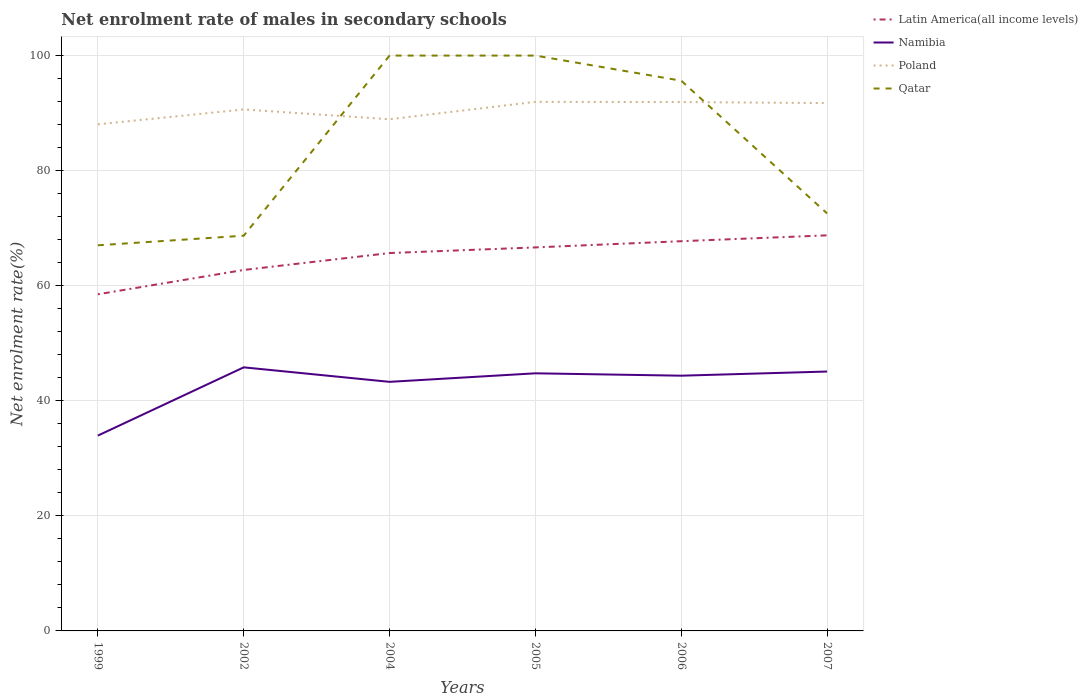Across all years, what is the maximum net enrolment rate of males in secondary schools in Namibia?
Offer a very short reply. 33.95. What is the total net enrolment rate of males in secondary schools in Poland in the graph?
Your response must be concise. -2.58. What is the difference between the highest and the second highest net enrolment rate of males in secondary schools in Poland?
Offer a terse response. 3.9. How many lines are there?
Your answer should be very brief. 4. How many years are there in the graph?
Provide a short and direct response. 6. Are the values on the major ticks of Y-axis written in scientific E-notation?
Ensure brevity in your answer.  No. How are the legend labels stacked?
Provide a succinct answer. Vertical. What is the title of the graph?
Make the answer very short. Net enrolment rate of males in secondary schools. Does "Ukraine" appear as one of the legend labels in the graph?
Provide a succinct answer. No. What is the label or title of the X-axis?
Provide a succinct answer. Years. What is the label or title of the Y-axis?
Provide a succinct answer. Net enrolment rate(%). What is the Net enrolment rate(%) of Latin America(all income levels) in 1999?
Offer a terse response. 58.51. What is the Net enrolment rate(%) in Namibia in 1999?
Your answer should be very brief. 33.95. What is the Net enrolment rate(%) of Poland in 1999?
Your response must be concise. 88.05. What is the Net enrolment rate(%) in Qatar in 1999?
Make the answer very short. 67.03. What is the Net enrolment rate(%) in Latin America(all income levels) in 2002?
Your answer should be compact. 62.74. What is the Net enrolment rate(%) in Namibia in 2002?
Give a very brief answer. 45.81. What is the Net enrolment rate(%) in Poland in 2002?
Keep it short and to the point. 90.64. What is the Net enrolment rate(%) of Qatar in 2002?
Offer a terse response. 68.69. What is the Net enrolment rate(%) of Latin America(all income levels) in 2004?
Give a very brief answer. 65.68. What is the Net enrolment rate(%) in Namibia in 2004?
Keep it short and to the point. 43.29. What is the Net enrolment rate(%) in Poland in 2004?
Offer a very short reply. 88.93. What is the Net enrolment rate(%) of Latin America(all income levels) in 2005?
Keep it short and to the point. 66.66. What is the Net enrolment rate(%) in Namibia in 2005?
Provide a short and direct response. 44.77. What is the Net enrolment rate(%) of Poland in 2005?
Your answer should be very brief. 91.96. What is the Net enrolment rate(%) in Latin America(all income levels) in 2006?
Your response must be concise. 67.74. What is the Net enrolment rate(%) in Namibia in 2006?
Your response must be concise. 44.36. What is the Net enrolment rate(%) in Poland in 2006?
Your response must be concise. 91.92. What is the Net enrolment rate(%) in Qatar in 2006?
Make the answer very short. 95.63. What is the Net enrolment rate(%) of Latin America(all income levels) in 2007?
Offer a terse response. 68.75. What is the Net enrolment rate(%) of Namibia in 2007?
Make the answer very short. 45.08. What is the Net enrolment rate(%) in Poland in 2007?
Offer a terse response. 91.74. What is the Net enrolment rate(%) in Qatar in 2007?
Give a very brief answer. 72.56. Across all years, what is the maximum Net enrolment rate(%) of Latin America(all income levels)?
Your answer should be very brief. 68.75. Across all years, what is the maximum Net enrolment rate(%) of Namibia?
Ensure brevity in your answer.  45.81. Across all years, what is the maximum Net enrolment rate(%) in Poland?
Offer a terse response. 91.96. Across all years, what is the minimum Net enrolment rate(%) in Latin America(all income levels)?
Keep it short and to the point. 58.51. Across all years, what is the minimum Net enrolment rate(%) in Namibia?
Your answer should be compact. 33.95. Across all years, what is the minimum Net enrolment rate(%) in Poland?
Provide a short and direct response. 88.05. Across all years, what is the minimum Net enrolment rate(%) in Qatar?
Ensure brevity in your answer.  67.03. What is the total Net enrolment rate(%) of Latin America(all income levels) in the graph?
Your answer should be compact. 390.08. What is the total Net enrolment rate(%) of Namibia in the graph?
Offer a very short reply. 257.27. What is the total Net enrolment rate(%) in Poland in the graph?
Give a very brief answer. 543.24. What is the total Net enrolment rate(%) in Qatar in the graph?
Offer a very short reply. 503.91. What is the difference between the Net enrolment rate(%) of Latin America(all income levels) in 1999 and that in 2002?
Give a very brief answer. -4.23. What is the difference between the Net enrolment rate(%) in Namibia in 1999 and that in 2002?
Offer a very short reply. -11.86. What is the difference between the Net enrolment rate(%) in Poland in 1999 and that in 2002?
Offer a very short reply. -2.58. What is the difference between the Net enrolment rate(%) of Qatar in 1999 and that in 2002?
Your answer should be compact. -1.67. What is the difference between the Net enrolment rate(%) of Latin America(all income levels) in 1999 and that in 2004?
Your answer should be very brief. -7.17. What is the difference between the Net enrolment rate(%) in Namibia in 1999 and that in 2004?
Offer a very short reply. -9.34. What is the difference between the Net enrolment rate(%) of Poland in 1999 and that in 2004?
Keep it short and to the point. -0.88. What is the difference between the Net enrolment rate(%) of Qatar in 1999 and that in 2004?
Your response must be concise. -32.97. What is the difference between the Net enrolment rate(%) in Latin America(all income levels) in 1999 and that in 2005?
Ensure brevity in your answer.  -8.15. What is the difference between the Net enrolment rate(%) in Namibia in 1999 and that in 2005?
Provide a succinct answer. -10.82. What is the difference between the Net enrolment rate(%) in Poland in 1999 and that in 2005?
Keep it short and to the point. -3.9. What is the difference between the Net enrolment rate(%) in Qatar in 1999 and that in 2005?
Keep it short and to the point. -32.97. What is the difference between the Net enrolment rate(%) of Latin America(all income levels) in 1999 and that in 2006?
Your answer should be compact. -9.23. What is the difference between the Net enrolment rate(%) of Namibia in 1999 and that in 2006?
Give a very brief answer. -10.41. What is the difference between the Net enrolment rate(%) of Poland in 1999 and that in 2006?
Make the answer very short. -3.87. What is the difference between the Net enrolment rate(%) in Qatar in 1999 and that in 2006?
Keep it short and to the point. -28.6. What is the difference between the Net enrolment rate(%) in Latin America(all income levels) in 1999 and that in 2007?
Your response must be concise. -10.24. What is the difference between the Net enrolment rate(%) in Namibia in 1999 and that in 2007?
Give a very brief answer. -11.13. What is the difference between the Net enrolment rate(%) of Poland in 1999 and that in 2007?
Give a very brief answer. -3.69. What is the difference between the Net enrolment rate(%) of Qatar in 1999 and that in 2007?
Your response must be concise. -5.53. What is the difference between the Net enrolment rate(%) of Latin America(all income levels) in 2002 and that in 2004?
Provide a short and direct response. -2.94. What is the difference between the Net enrolment rate(%) in Namibia in 2002 and that in 2004?
Ensure brevity in your answer.  2.52. What is the difference between the Net enrolment rate(%) of Poland in 2002 and that in 2004?
Your answer should be compact. 1.71. What is the difference between the Net enrolment rate(%) in Qatar in 2002 and that in 2004?
Ensure brevity in your answer.  -31.31. What is the difference between the Net enrolment rate(%) in Latin America(all income levels) in 2002 and that in 2005?
Give a very brief answer. -3.92. What is the difference between the Net enrolment rate(%) in Namibia in 2002 and that in 2005?
Make the answer very short. 1.04. What is the difference between the Net enrolment rate(%) in Poland in 2002 and that in 2005?
Make the answer very short. -1.32. What is the difference between the Net enrolment rate(%) of Qatar in 2002 and that in 2005?
Offer a very short reply. -31.31. What is the difference between the Net enrolment rate(%) of Latin America(all income levels) in 2002 and that in 2006?
Provide a short and direct response. -5. What is the difference between the Net enrolment rate(%) in Namibia in 2002 and that in 2006?
Ensure brevity in your answer.  1.45. What is the difference between the Net enrolment rate(%) of Poland in 2002 and that in 2006?
Offer a very short reply. -1.29. What is the difference between the Net enrolment rate(%) of Qatar in 2002 and that in 2006?
Offer a terse response. -26.94. What is the difference between the Net enrolment rate(%) of Latin America(all income levels) in 2002 and that in 2007?
Offer a terse response. -6.02. What is the difference between the Net enrolment rate(%) of Namibia in 2002 and that in 2007?
Keep it short and to the point. 0.73. What is the difference between the Net enrolment rate(%) of Poland in 2002 and that in 2007?
Your answer should be compact. -1.11. What is the difference between the Net enrolment rate(%) of Qatar in 2002 and that in 2007?
Your answer should be very brief. -3.87. What is the difference between the Net enrolment rate(%) in Latin America(all income levels) in 2004 and that in 2005?
Ensure brevity in your answer.  -0.98. What is the difference between the Net enrolment rate(%) in Namibia in 2004 and that in 2005?
Provide a short and direct response. -1.48. What is the difference between the Net enrolment rate(%) of Poland in 2004 and that in 2005?
Provide a succinct answer. -3.03. What is the difference between the Net enrolment rate(%) of Qatar in 2004 and that in 2005?
Provide a succinct answer. 0. What is the difference between the Net enrolment rate(%) of Latin America(all income levels) in 2004 and that in 2006?
Offer a very short reply. -2.06. What is the difference between the Net enrolment rate(%) of Namibia in 2004 and that in 2006?
Provide a short and direct response. -1.07. What is the difference between the Net enrolment rate(%) in Poland in 2004 and that in 2006?
Offer a very short reply. -2.99. What is the difference between the Net enrolment rate(%) in Qatar in 2004 and that in 2006?
Your answer should be compact. 4.37. What is the difference between the Net enrolment rate(%) in Latin America(all income levels) in 2004 and that in 2007?
Keep it short and to the point. -3.08. What is the difference between the Net enrolment rate(%) of Namibia in 2004 and that in 2007?
Your answer should be very brief. -1.79. What is the difference between the Net enrolment rate(%) in Poland in 2004 and that in 2007?
Keep it short and to the point. -2.81. What is the difference between the Net enrolment rate(%) of Qatar in 2004 and that in 2007?
Your answer should be compact. 27.44. What is the difference between the Net enrolment rate(%) of Latin America(all income levels) in 2005 and that in 2006?
Offer a terse response. -1.08. What is the difference between the Net enrolment rate(%) in Namibia in 2005 and that in 2006?
Your answer should be compact. 0.41. What is the difference between the Net enrolment rate(%) in Poland in 2005 and that in 2006?
Provide a succinct answer. 0.03. What is the difference between the Net enrolment rate(%) of Qatar in 2005 and that in 2006?
Offer a very short reply. 4.37. What is the difference between the Net enrolment rate(%) of Latin America(all income levels) in 2005 and that in 2007?
Make the answer very short. -2.1. What is the difference between the Net enrolment rate(%) of Namibia in 2005 and that in 2007?
Your answer should be very brief. -0.31. What is the difference between the Net enrolment rate(%) in Poland in 2005 and that in 2007?
Ensure brevity in your answer.  0.21. What is the difference between the Net enrolment rate(%) in Qatar in 2005 and that in 2007?
Offer a terse response. 27.44. What is the difference between the Net enrolment rate(%) of Latin America(all income levels) in 2006 and that in 2007?
Ensure brevity in your answer.  -1.02. What is the difference between the Net enrolment rate(%) of Namibia in 2006 and that in 2007?
Your answer should be compact. -0.72. What is the difference between the Net enrolment rate(%) of Poland in 2006 and that in 2007?
Give a very brief answer. 0.18. What is the difference between the Net enrolment rate(%) in Qatar in 2006 and that in 2007?
Provide a short and direct response. 23.07. What is the difference between the Net enrolment rate(%) of Latin America(all income levels) in 1999 and the Net enrolment rate(%) of Namibia in 2002?
Offer a very short reply. 12.7. What is the difference between the Net enrolment rate(%) in Latin America(all income levels) in 1999 and the Net enrolment rate(%) in Poland in 2002?
Your answer should be very brief. -32.12. What is the difference between the Net enrolment rate(%) in Latin America(all income levels) in 1999 and the Net enrolment rate(%) in Qatar in 2002?
Ensure brevity in your answer.  -10.18. What is the difference between the Net enrolment rate(%) of Namibia in 1999 and the Net enrolment rate(%) of Poland in 2002?
Provide a short and direct response. -56.69. What is the difference between the Net enrolment rate(%) in Namibia in 1999 and the Net enrolment rate(%) in Qatar in 2002?
Provide a succinct answer. -34.74. What is the difference between the Net enrolment rate(%) of Poland in 1999 and the Net enrolment rate(%) of Qatar in 2002?
Provide a short and direct response. 19.36. What is the difference between the Net enrolment rate(%) of Latin America(all income levels) in 1999 and the Net enrolment rate(%) of Namibia in 2004?
Give a very brief answer. 15.22. What is the difference between the Net enrolment rate(%) of Latin America(all income levels) in 1999 and the Net enrolment rate(%) of Poland in 2004?
Your response must be concise. -30.42. What is the difference between the Net enrolment rate(%) of Latin America(all income levels) in 1999 and the Net enrolment rate(%) of Qatar in 2004?
Ensure brevity in your answer.  -41.49. What is the difference between the Net enrolment rate(%) of Namibia in 1999 and the Net enrolment rate(%) of Poland in 2004?
Offer a terse response. -54.98. What is the difference between the Net enrolment rate(%) of Namibia in 1999 and the Net enrolment rate(%) of Qatar in 2004?
Provide a short and direct response. -66.05. What is the difference between the Net enrolment rate(%) of Poland in 1999 and the Net enrolment rate(%) of Qatar in 2004?
Offer a very short reply. -11.95. What is the difference between the Net enrolment rate(%) in Latin America(all income levels) in 1999 and the Net enrolment rate(%) in Namibia in 2005?
Offer a terse response. 13.74. What is the difference between the Net enrolment rate(%) of Latin America(all income levels) in 1999 and the Net enrolment rate(%) of Poland in 2005?
Keep it short and to the point. -33.45. What is the difference between the Net enrolment rate(%) in Latin America(all income levels) in 1999 and the Net enrolment rate(%) in Qatar in 2005?
Offer a terse response. -41.49. What is the difference between the Net enrolment rate(%) in Namibia in 1999 and the Net enrolment rate(%) in Poland in 2005?
Your response must be concise. -58.01. What is the difference between the Net enrolment rate(%) in Namibia in 1999 and the Net enrolment rate(%) in Qatar in 2005?
Your answer should be very brief. -66.05. What is the difference between the Net enrolment rate(%) in Poland in 1999 and the Net enrolment rate(%) in Qatar in 2005?
Keep it short and to the point. -11.95. What is the difference between the Net enrolment rate(%) in Latin America(all income levels) in 1999 and the Net enrolment rate(%) in Namibia in 2006?
Provide a succinct answer. 14.15. What is the difference between the Net enrolment rate(%) in Latin America(all income levels) in 1999 and the Net enrolment rate(%) in Poland in 2006?
Make the answer very short. -33.41. What is the difference between the Net enrolment rate(%) of Latin America(all income levels) in 1999 and the Net enrolment rate(%) of Qatar in 2006?
Give a very brief answer. -37.12. What is the difference between the Net enrolment rate(%) in Namibia in 1999 and the Net enrolment rate(%) in Poland in 2006?
Your response must be concise. -57.97. What is the difference between the Net enrolment rate(%) of Namibia in 1999 and the Net enrolment rate(%) of Qatar in 2006?
Ensure brevity in your answer.  -61.68. What is the difference between the Net enrolment rate(%) of Poland in 1999 and the Net enrolment rate(%) of Qatar in 2006?
Keep it short and to the point. -7.58. What is the difference between the Net enrolment rate(%) in Latin America(all income levels) in 1999 and the Net enrolment rate(%) in Namibia in 2007?
Make the answer very short. 13.43. What is the difference between the Net enrolment rate(%) of Latin America(all income levels) in 1999 and the Net enrolment rate(%) of Poland in 2007?
Provide a succinct answer. -33.23. What is the difference between the Net enrolment rate(%) in Latin America(all income levels) in 1999 and the Net enrolment rate(%) in Qatar in 2007?
Provide a succinct answer. -14.05. What is the difference between the Net enrolment rate(%) in Namibia in 1999 and the Net enrolment rate(%) in Poland in 2007?
Offer a terse response. -57.79. What is the difference between the Net enrolment rate(%) in Namibia in 1999 and the Net enrolment rate(%) in Qatar in 2007?
Your answer should be very brief. -38.61. What is the difference between the Net enrolment rate(%) in Poland in 1999 and the Net enrolment rate(%) in Qatar in 2007?
Provide a succinct answer. 15.49. What is the difference between the Net enrolment rate(%) in Latin America(all income levels) in 2002 and the Net enrolment rate(%) in Namibia in 2004?
Offer a terse response. 19.45. What is the difference between the Net enrolment rate(%) in Latin America(all income levels) in 2002 and the Net enrolment rate(%) in Poland in 2004?
Your answer should be very brief. -26.19. What is the difference between the Net enrolment rate(%) in Latin America(all income levels) in 2002 and the Net enrolment rate(%) in Qatar in 2004?
Provide a short and direct response. -37.26. What is the difference between the Net enrolment rate(%) of Namibia in 2002 and the Net enrolment rate(%) of Poland in 2004?
Give a very brief answer. -43.12. What is the difference between the Net enrolment rate(%) in Namibia in 2002 and the Net enrolment rate(%) in Qatar in 2004?
Ensure brevity in your answer.  -54.19. What is the difference between the Net enrolment rate(%) of Poland in 2002 and the Net enrolment rate(%) of Qatar in 2004?
Ensure brevity in your answer.  -9.36. What is the difference between the Net enrolment rate(%) in Latin America(all income levels) in 2002 and the Net enrolment rate(%) in Namibia in 2005?
Make the answer very short. 17.97. What is the difference between the Net enrolment rate(%) of Latin America(all income levels) in 2002 and the Net enrolment rate(%) of Poland in 2005?
Provide a succinct answer. -29.22. What is the difference between the Net enrolment rate(%) of Latin America(all income levels) in 2002 and the Net enrolment rate(%) of Qatar in 2005?
Your response must be concise. -37.26. What is the difference between the Net enrolment rate(%) in Namibia in 2002 and the Net enrolment rate(%) in Poland in 2005?
Ensure brevity in your answer.  -46.14. What is the difference between the Net enrolment rate(%) in Namibia in 2002 and the Net enrolment rate(%) in Qatar in 2005?
Your response must be concise. -54.19. What is the difference between the Net enrolment rate(%) of Poland in 2002 and the Net enrolment rate(%) of Qatar in 2005?
Offer a terse response. -9.36. What is the difference between the Net enrolment rate(%) in Latin America(all income levels) in 2002 and the Net enrolment rate(%) in Namibia in 2006?
Offer a terse response. 18.38. What is the difference between the Net enrolment rate(%) of Latin America(all income levels) in 2002 and the Net enrolment rate(%) of Poland in 2006?
Offer a very short reply. -29.18. What is the difference between the Net enrolment rate(%) of Latin America(all income levels) in 2002 and the Net enrolment rate(%) of Qatar in 2006?
Your answer should be very brief. -32.89. What is the difference between the Net enrolment rate(%) in Namibia in 2002 and the Net enrolment rate(%) in Poland in 2006?
Give a very brief answer. -46.11. What is the difference between the Net enrolment rate(%) of Namibia in 2002 and the Net enrolment rate(%) of Qatar in 2006?
Your response must be concise. -49.82. What is the difference between the Net enrolment rate(%) in Poland in 2002 and the Net enrolment rate(%) in Qatar in 2006?
Provide a short and direct response. -5. What is the difference between the Net enrolment rate(%) of Latin America(all income levels) in 2002 and the Net enrolment rate(%) of Namibia in 2007?
Make the answer very short. 17.66. What is the difference between the Net enrolment rate(%) in Latin America(all income levels) in 2002 and the Net enrolment rate(%) in Poland in 2007?
Provide a short and direct response. -29. What is the difference between the Net enrolment rate(%) of Latin America(all income levels) in 2002 and the Net enrolment rate(%) of Qatar in 2007?
Offer a terse response. -9.82. What is the difference between the Net enrolment rate(%) in Namibia in 2002 and the Net enrolment rate(%) in Poland in 2007?
Your answer should be compact. -45.93. What is the difference between the Net enrolment rate(%) of Namibia in 2002 and the Net enrolment rate(%) of Qatar in 2007?
Your response must be concise. -26.75. What is the difference between the Net enrolment rate(%) of Poland in 2002 and the Net enrolment rate(%) of Qatar in 2007?
Make the answer very short. 18.08. What is the difference between the Net enrolment rate(%) in Latin America(all income levels) in 2004 and the Net enrolment rate(%) in Namibia in 2005?
Ensure brevity in your answer.  20.9. What is the difference between the Net enrolment rate(%) of Latin America(all income levels) in 2004 and the Net enrolment rate(%) of Poland in 2005?
Provide a short and direct response. -26.28. What is the difference between the Net enrolment rate(%) of Latin America(all income levels) in 2004 and the Net enrolment rate(%) of Qatar in 2005?
Offer a very short reply. -34.32. What is the difference between the Net enrolment rate(%) of Namibia in 2004 and the Net enrolment rate(%) of Poland in 2005?
Your answer should be very brief. -48.66. What is the difference between the Net enrolment rate(%) of Namibia in 2004 and the Net enrolment rate(%) of Qatar in 2005?
Offer a very short reply. -56.71. What is the difference between the Net enrolment rate(%) in Poland in 2004 and the Net enrolment rate(%) in Qatar in 2005?
Your response must be concise. -11.07. What is the difference between the Net enrolment rate(%) in Latin America(all income levels) in 2004 and the Net enrolment rate(%) in Namibia in 2006?
Offer a very short reply. 21.32. What is the difference between the Net enrolment rate(%) of Latin America(all income levels) in 2004 and the Net enrolment rate(%) of Poland in 2006?
Make the answer very short. -26.25. What is the difference between the Net enrolment rate(%) in Latin America(all income levels) in 2004 and the Net enrolment rate(%) in Qatar in 2006?
Your response must be concise. -29.95. What is the difference between the Net enrolment rate(%) in Namibia in 2004 and the Net enrolment rate(%) in Poland in 2006?
Your answer should be compact. -48.63. What is the difference between the Net enrolment rate(%) in Namibia in 2004 and the Net enrolment rate(%) in Qatar in 2006?
Give a very brief answer. -52.34. What is the difference between the Net enrolment rate(%) in Poland in 2004 and the Net enrolment rate(%) in Qatar in 2006?
Your answer should be very brief. -6.7. What is the difference between the Net enrolment rate(%) in Latin America(all income levels) in 2004 and the Net enrolment rate(%) in Namibia in 2007?
Provide a succinct answer. 20.59. What is the difference between the Net enrolment rate(%) of Latin America(all income levels) in 2004 and the Net enrolment rate(%) of Poland in 2007?
Your response must be concise. -26.06. What is the difference between the Net enrolment rate(%) of Latin America(all income levels) in 2004 and the Net enrolment rate(%) of Qatar in 2007?
Give a very brief answer. -6.88. What is the difference between the Net enrolment rate(%) in Namibia in 2004 and the Net enrolment rate(%) in Poland in 2007?
Keep it short and to the point. -48.45. What is the difference between the Net enrolment rate(%) of Namibia in 2004 and the Net enrolment rate(%) of Qatar in 2007?
Offer a very short reply. -29.27. What is the difference between the Net enrolment rate(%) in Poland in 2004 and the Net enrolment rate(%) in Qatar in 2007?
Offer a very short reply. 16.37. What is the difference between the Net enrolment rate(%) of Latin America(all income levels) in 2005 and the Net enrolment rate(%) of Namibia in 2006?
Offer a terse response. 22.3. What is the difference between the Net enrolment rate(%) of Latin America(all income levels) in 2005 and the Net enrolment rate(%) of Poland in 2006?
Your answer should be very brief. -25.27. What is the difference between the Net enrolment rate(%) of Latin America(all income levels) in 2005 and the Net enrolment rate(%) of Qatar in 2006?
Keep it short and to the point. -28.97. What is the difference between the Net enrolment rate(%) of Namibia in 2005 and the Net enrolment rate(%) of Poland in 2006?
Keep it short and to the point. -47.15. What is the difference between the Net enrolment rate(%) in Namibia in 2005 and the Net enrolment rate(%) in Qatar in 2006?
Ensure brevity in your answer.  -50.86. What is the difference between the Net enrolment rate(%) of Poland in 2005 and the Net enrolment rate(%) of Qatar in 2006?
Make the answer very short. -3.67. What is the difference between the Net enrolment rate(%) in Latin America(all income levels) in 2005 and the Net enrolment rate(%) in Namibia in 2007?
Your answer should be very brief. 21.57. What is the difference between the Net enrolment rate(%) of Latin America(all income levels) in 2005 and the Net enrolment rate(%) of Poland in 2007?
Your response must be concise. -25.08. What is the difference between the Net enrolment rate(%) in Latin America(all income levels) in 2005 and the Net enrolment rate(%) in Qatar in 2007?
Provide a short and direct response. -5.9. What is the difference between the Net enrolment rate(%) of Namibia in 2005 and the Net enrolment rate(%) of Poland in 2007?
Your response must be concise. -46.97. What is the difference between the Net enrolment rate(%) in Namibia in 2005 and the Net enrolment rate(%) in Qatar in 2007?
Give a very brief answer. -27.78. What is the difference between the Net enrolment rate(%) of Poland in 2005 and the Net enrolment rate(%) of Qatar in 2007?
Keep it short and to the point. 19.4. What is the difference between the Net enrolment rate(%) of Latin America(all income levels) in 2006 and the Net enrolment rate(%) of Namibia in 2007?
Offer a very short reply. 22.65. What is the difference between the Net enrolment rate(%) in Latin America(all income levels) in 2006 and the Net enrolment rate(%) in Poland in 2007?
Your answer should be very brief. -24.01. What is the difference between the Net enrolment rate(%) of Latin America(all income levels) in 2006 and the Net enrolment rate(%) of Qatar in 2007?
Keep it short and to the point. -4.82. What is the difference between the Net enrolment rate(%) of Namibia in 2006 and the Net enrolment rate(%) of Poland in 2007?
Keep it short and to the point. -47.38. What is the difference between the Net enrolment rate(%) in Namibia in 2006 and the Net enrolment rate(%) in Qatar in 2007?
Ensure brevity in your answer.  -28.2. What is the difference between the Net enrolment rate(%) of Poland in 2006 and the Net enrolment rate(%) of Qatar in 2007?
Make the answer very short. 19.37. What is the average Net enrolment rate(%) of Latin America(all income levels) per year?
Ensure brevity in your answer.  65.01. What is the average Net enrolment rate(%) in Namibia per year?
Provide a succinct answer. 42.88. What is the average Net enrolment rate(%) of Poland per year?
Offer a terse response. 90.54. What is the average Net enrolment rate(%) in Qatar per year?
Keep it short and to the point. 83.98. In the year 1999, what is the difference between the Net enrolment rate(%) in Latin America(all income levels) and Net enrolment rate(%) in Namibia?
Give a very brief answer. 24.56. In the year 1999, what is the difference between the Net enrolment rate(%) in Latin America(all income levels) and Net enrolment rate(%) in Poland?
Keep it short and to the point. -29.54. In the year 1999, what is the difference between the Net enrolment rate(%) of Latin America(all income levels) and Net enrolment rate(%) of Qatar?
Provide a succinct answer. -8.52. In the year 1999, what is the difference between the Net enrolment rate(%) in Namibia and Net enrolment rate(%) in Poland?
Offer a very short reply. -54.1. In the year 1999, what is the difference between the Net enrolment rate(%) in Namibia and Net enrolment rate(%) in Qatar?
Ensure brevity in your answer.  -33.08. In the year 1999, what is the difference between the Net enrolment rate(%) of Poland and Net enrolment rate(%) of Qatar?
Your answer should be very brief. 21.03. In the year 2002, what is the difference between the Net enrolment rate(%) of Latin America(all income levels) and Net enrolment rate(%) of Namibia?
Your answer should be compact. 16.93. In the year 2002, what is the difference between the Net enrolment rate(%) of Latin America(all income levels) and Net enrolment rate(%) of Poland?
Offer a very short reply. -27.9. In the year 2002, what is the difference between the Net enrolment rate(%) of Latin America(all income levels) and Net enrolment rate(%) of Qatar?
Give a very brief answer. -5.95. In the year 2002, what is the difference between the Net enrolment rate(%) in Namibia and Net enrolment rate(%) in Poland?
Provide a succinct answer. -44.82. In the year 2002, what is the difference between the Net enrolment rate(%) of Namibia and Net enrolment rate(%) of Qatar?
Provide a succinct answer. -22.88. In the year 2002, what is the difference between the Net enrolment rate(%) of Poland and Net enrolment rate(%) of Qatar?
Make the answer very short. 21.94. In the year 2004, what is the difference between the Net enrolment rate(%) of Latin America(all income levels) and Net enrolment rate(%) of Namibia?
Your response must be concise. 22.39. In the year 2004, what is the difference between the Net enrolment rate(%) in Latin America(all income levels) and Net enrolment rate(%) in Poland?
Provide a short and direct response. -23.25. In the year 2004, what is the difference between the Net enrolment rate(%) of Latin America(all income levels) and Net enrolment rate(%) of Qatar?
Make the answer very short. -34.32. In the year 2004, what is the difference between the Net enrolment rate(%) in Namibia and Net enrolment rate(%) in Poland?
Your answer should be very brief. -45.64. In the year 2004, what is the difference between the Net enrolment rate(%) in Namibia and Net enrolment rate(%) in Qatar?
Ensure brevity in your answer.  -56.71. In the year 2004, what is the difference between the Net enrolment rate(%) in Poland and Net enrolment rate(%) in Qatar?
Your answer should be compact. -11.07. In the year 2005, what is the difference between the Net enrolment rate(%) in Latin America(all income levels) and Net enrolment rate(%) in Namibia?
Provide a succinct answer. 21.88. In the year 2005, what is the difference between the Net enrolment rate(%) in Latin America(all income levels) and Net enrolment rate(%) in Poland?
Keep it short and to the point. -25.3. In the year 2005, what is the difference between the Net enrolment rate(%) in Latin America(all income levels) and Net enrolment rate(%) in Qatar?
Keep it short and to the point. -33.34. In the year 2005, what is the difference between the Net enrolment rate(%) in Namibia and Net enrolment rate(%) in Poland?
Provide a short and direct response. -47.18. In the year 2005, what is the difference between the Net enrolment rate(%) in Namibia and Net enrolment rate(%) in Qatar?
Provide a succinct answer. -55.23. In the year 2005, what is the difference between the Net enrolment rate(%) of Poland and Net enrolment rate(%) of Qatar?
Provide a succinct answer. -8.04. In the year 2006, what is the difference between the Net enrolment rate(%) in Latin America(all income levels) and Net enrolment rate(%) in Namibia?
Provide a short and direct response. 23.37. In the year 2006, what is the difference between the Net enrolment rate(%) of Latin America(all income levels) and Net enrolment rate(%) of Poland?
Your answer should be compact. -24.19. In the year 2006, what is the difference between the Net enrolment rate(%) in Latin America(all income levels) and Net enrolment rate(%) in Qatar?
Your response must be concise. -27.89. In the year 2006, what is the difference between the Net enrolment rate(%) of Namibia and Net enrolment rate(%) of Poland?
Give a very brief answer. -47.56. In the year 2006, what is the difference between the Net enrolment rate(%) of Namibia and Net enrolment rate(%) of Qatar?
Offer a terse response. -51.27. In the year 2006, what is the difference between the Net enrolment rate(%) in Poland and Net enrolment rate(%) in Qatar?
Offer a terse response. -3.71. In the year 2007, what is the difference between the Net enrolment rate(%) in Latin America(all income levels) and Net enrolment rate(%) in Namibia?
Provide a succinct answer. 23.67. In the year 2007, what is the difference between the Net enrolment rate(%) in Latin America(all income levels) and Net enrolment rate(%) in Poland?
Provide a succinct answer. -22.99. In the year 2007, what is the difference between the Net enrolment rate(%) of Latin America(all income levels) and Net enrolment rate(%) of Qatar?
Keep it short and to the point. -3.8. In the year 2007, what is the difference between the Net enrolment rate(%) of Namibia and Net enrolment rate(%) of Poland?
Your answer should be very brief. -46.66. In the year 2007, what is the difference between the Net enrolment rate(%) in Namibia and Net enrolment rate(%) in Qatar?
Your response must be concise. -27.47. In the year 2007, what is the difference between the Net enrolment rate(%) of Poland and Net enrolment rate(%) of Qatar?
Your response must be concise. 19.18. What is the ratio of the Net enrolment rate(%) of Latin America(all income levels) in 1999 to that in 2002?
Your answer should be compact. 0.93. What is the ratio of the Net enrolment rate(%) in Namibia in 1999 to that in 2002?
Ensure brevity in your answer.  0.74. What is the ratio of the Net enrolment rate(%) in Poland in 1999 to that in 2002?
Ensure brevity in your answer.  0.97. What is the ratio of the Net enrolment rate(%) of Qatar in 1999 to that in 2002?
Provide a succinct answer. 0.98. What is the ratio of the Net enrolment rate(%) in Latin America(all income levels) in 1999 to that in 2004?
Provide a succinct answer. 0.89. What is the ratio of the Net enrolment rate(%) of Namibia in 1999 to that in 2004?
Your answer should be very brief. 0.78. What is the ratio of the Net enrolment rate(%) of Poland in 1999 to that in 2004?
Your answer should be compact. 0.99. What is the ratio of the Net enrolment rate(%) in Qatar in 1999 to that in 2004?
Your answer should be very brief. 0.67. What is the ratio of the Net enrolment rate(%) of Latin America(all income levels) in 1999 to that in 2005?
Offer a very short reply. 0.88. What is the ratio of the Net enrolment rate(%) of Namibia in 1999 to that in 2005?
Ensure brevity in your answer.  0.76. What is the ratio of the Net enrolment rate(%) of Poland in 1999 to that in 2005?
Give a very brief answer. 0.96. What is the ratio of the Net enrolment rate(%) of Qatar in 1999 to that in 2005?
Provide a succinct answer. 0.67. What is the ratio of the Net enrolment rate(%) of Latin America(all income levels) in 1999 to that in 2006?
Ensure brevity in your answer.  0.86. What is the ratio of the Net enrolment rate(%) in Namibia in 1999 to that in 2006?
Your answer should be compact. 0.77. What is the ratio of the Net enrolment rate(%) of Poland in 1999 to that in 2006?
Give a very brief answer. 0.96. What is the ratio of the Net enrolment rate(%) in Qatar in 1999 to that in 2006?
Your response must be concise. 0.7. What is the ratio of the Net enrolment rate(%) in Latin America(all income levels) in 1999 to that in 2007?
Your answer should be very brief. 0.85. What is the ratio of the Net enrolment rate(%) in Namibia in 1999 to that in 2007?
Your answer should be very brief. 0.75. What is the ratio of the Net enrolment rate(%) of Poland in 1999 to that in 2007?
Your answer should be very brief. 0.96. What is the ratio of the Net enrolment rate(%) of Qatar in 1999 to that in 2007?
Make the answer very short. 0.92. What is the ratio of the Net enrolment rate(%) in Latin America(all income levels) in 2002 to that in 2004?
Ensure brevity in your answer.  0.96. What is the ratio of the Net enrolment rate(%) in Namibia in 2002 to that in 2004?
Provide a short and direct response. 1.06. What is the ratio of the Net enrolment rate(%) in Poland in 2002 to that in 2004?
Your response must be concise. 1.02. What is the ratio of the Net enrolment rate(%) in Qatar in 2002 to that in 2004?
Give a very brief answer. 0.69. What is the ratio of the Net enrolment rate(%) of Latin America(all income levels) in 2002 to that in 2005?
Your response must be concise. 0.94. What is the ratio of the Net enrolment rate(%) in Namibia in 2002 to that in 2005?
Your answer should be very brief. 1.02. What is the ratio of the Net enrolment rate(%) in Poland in 2002 to that in 2005?
Make the answer very short. 0.99. What is the ratio of the Net enrolment rate(%) of Qatar in 2002 to that in 2005?
Provide a short and direct response. 0.69. What is the ratio of the Net enrolment rate(%) of Latin America(all income levels) in 2002 to that in 2006?
Provide a short and direct response. 0.93. What is the ratio of the Net enrolment rate(%) of Namibia in 2002 to that in 2006?
Provide a short and direct response. 1.03. What is the ratio of the Net enrolment rate(%) in Poland in 2002 to that in 2006?
Your answer should be very brief. 0.99. What is the ratio of the Net enrolment rate(%) in Qatar in 2002 to that in 2006?
Give a very brief answer. 0.72. What is the ratio of the Net enrolment rate(%) of Latin America(all income levels) in 2002 to that in 2007?
Make the answer very short. 0.91. What is the ratio of the Net enrolment rate(%) in Namibia in 2002 to that in 2007?
Make the answer very short. 1.02. What is the ratio of the Net enrolment rate(%) of Poland in 2002 to that in 2007?
Your answer should be compact. 0.99. What is the ratio of the Net enrolment rate(%) of Qatar in 2002 to that in 2007?
Your response must be concise. 0.95. What is the ratio of the Net enrolment rate(%) of Latin America(all income levels) in 2004 to that in 2005?
Offer a terse response. 0.99. What is the ratio of the Net enrolment rate(%) in Namibia in 2004 to that in 2005?
Make the answer very short. 0.97. What is the ratio of the Net enrolment rate(%) of Poland in 2004 to that in 2005?
Provide a succinct answer. 0.97. What is the ratio of the Net enrolment rate(%) of Qatar in 2004 to that in 2005?
Offer a very short reply. 1. What is the ratio of the Net enrolment rate(%) of Latin America(all income levels) in 2004 to that in 2006?
Offer a very short reply. 0.97. What is the ratio of the Net enrolment rate(%) of Namibia in 2004 to that in 2006?
Your answer should be very brief. 0.98. What is the ratio of the Net enrolment rate(%) in Poland in 2004 to that in 2006?
Make the answer very short. 0.97. What is the ratio of the Net enrolment rate(%) in Qatar in 2004 to that in 2006?
Give a very brief answer. 1.05. What is the ratio of the Net enrolment rate(%) in Latin America(all income levels) in 2004 to that in 2007?
Provide a short and direct response. 0.96. What is the ratio of the Net enrolment rate(%) in Namibia in 2004 to that in 2007?
Your answer should be very brief. 0.96. What is the ratio of the Net enrolment rate(%) of Poland in 2004 to that in 2007?
Your answer should be compact. 0.97. What is the ratio of the Net enrolment rate(%) in Qatar in 2004 to that in 2007?
Your answer should be very brief. 1.38. What is the ratio of the Net enrolment rate(%) in Latin America(all income levels) in 2005 to that in 2006?
Your answer should be very brief. 0.98. What is the ratio of the Net enrolment rate(%) in Namibia in 2005 to that in 2006?
Your answer should be compact. 1.01. What is the ratio of the Net enrolment rate(%) in Poland in 2005 to that in 2006?
Make the answer very short. 1. What is the ratio of the Net enrolment rate(%) in Qatar in 2005 to that in 2006?
Your response must be concise. 1.05. What is the ratio of the Net enrolment rate(%) of Latin America(all income levels) in 2005 to that in 2007?
Give a very brief answer. 0.97. What is the ratio of the Net enrolment rate(%) of Qatar in 2005 to that in 2007?
Your answer should be compact. 1.38. What is the ratio of the Net enrolment rate(%) of Latin America(all income levels) in 2006 to that in 2007?
Your response must be concise. 0.99. What is the ratio of the Net enrolment rate(%) of Poland in 2006 to that in 2007?
Keep it short and to the point. 1. What is the ratio of the Net enrolment rate(%) of Qatar in 2006 to that in 2007?
Keep it short and to the point. 1.32. What is the difference between the highest and the second highest Net enrolment rate(%) in Latin America(all income levels)?
Make the answer very short. 1.02. What is the difference between the highest and the second highest Net enrolment rate(%) of Namibia?
Your answer should be very brief. 0.73. What is the difference between the highest and the second highest Net enrolment rate(%) of Poland?
Offer a terse response. 0.03. What is the difference between the highest and the lowest Net enrolment rate(%) of Latin America(all income levels)?
Your answer should be compact. 10.24. What is the difference between the highest and the lowest Net enrolment rate(%) in Namibia?
Your answer should be very brief. 11.86. What is the difference between the highest and the lowest Net enrolment rate(%) of Poland?
Make the answer very short. 3.9. What is the difference between the highest and the lowest Net enrolment rate(%) of Qatar?
Provide a succinct answer. 32.97. 